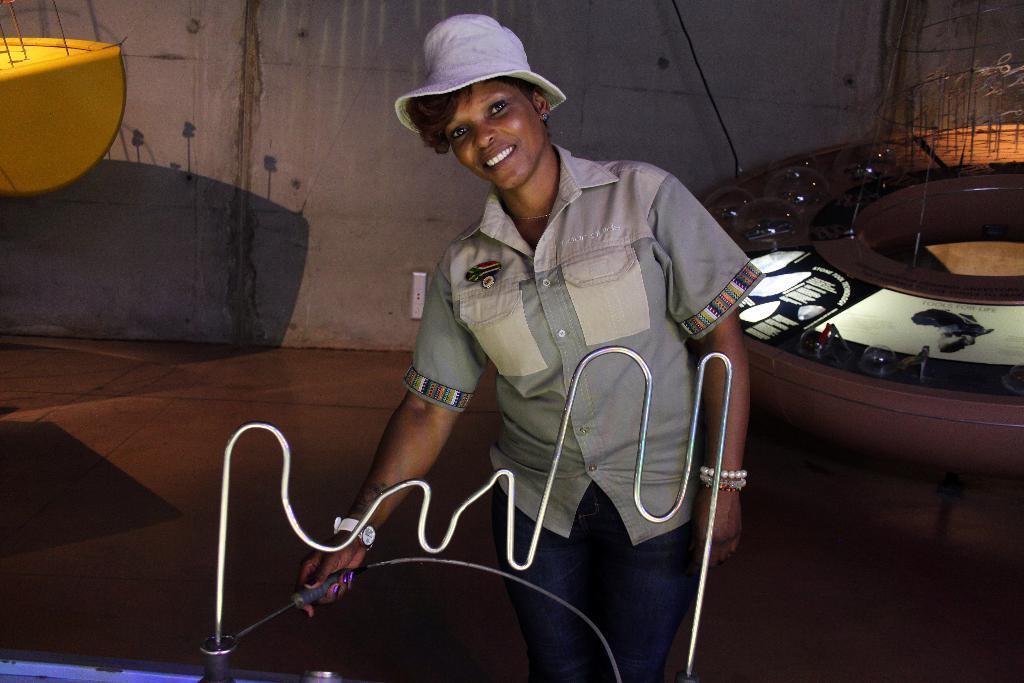Describe this image in one or two sentences. In this picture there is a lady in the center of the image, by holding a metal stick in her hand. 